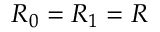Convert formula to latex. <formula><loc_0><loc_0><loc_500><loc_500>R _ { 0 } = R _ { 1 } = R</formula> 